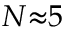<formula> <loc_0><loc_0><loc_500><loc_500>N { \approx } 5</formula> 